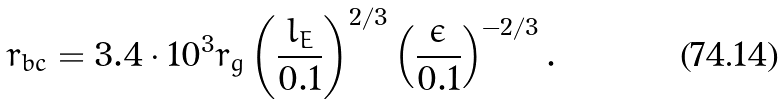<formula> <loc_0><loc_0><loc_500><loc_500>r _ { b c } = 3 . 4 \cdot 1 0 ^ { 3 } r _ { g } \left ( \frac { l _ { E } } { 0 . 1 } \right ) ^ { 2 / 3 } \left ( \frac { \epsilon } { 0 . 1 } \right ) ^ { - 2 / 3 } .</formula> 